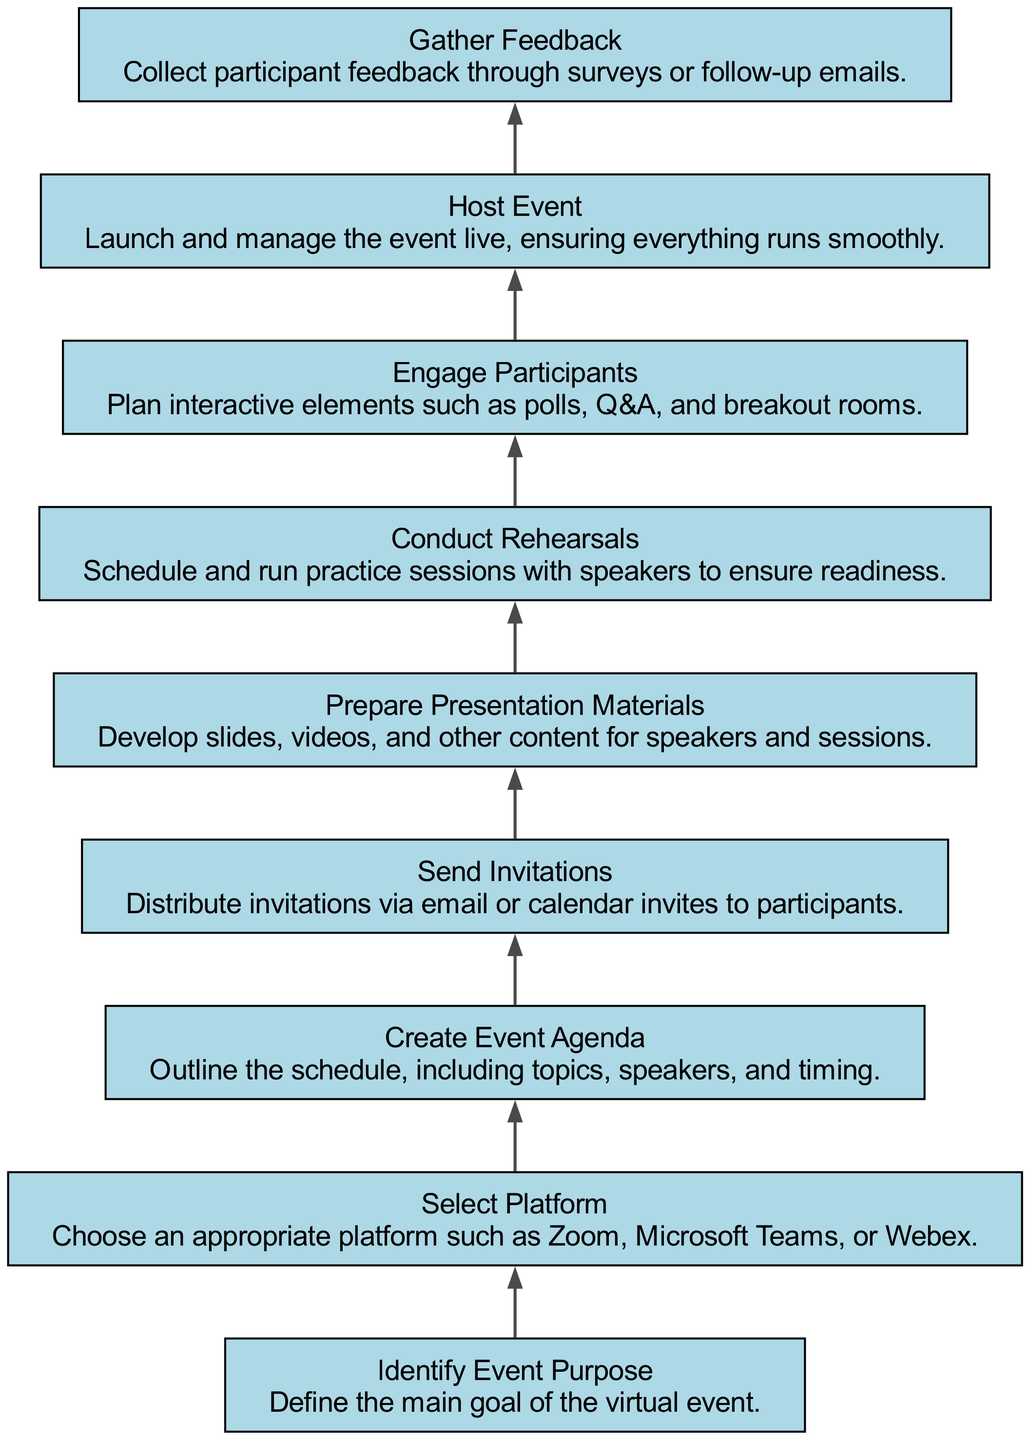What is the last step in organizing a virtual event? The last step in the diagram is "Gather Feedback," which is the final process after the event is hosted.
Answer: Gather Feedback How many elements are in the flow chart? There are nine elements represented as nodes in the flow chart. Each step in the organization of the virtual event is a distinct element.
Answer: Nine Which step directly follows "Send Invitations"? "Prepare Presentation Materials" directly follows "Send Invitations" in the flow of the diagram. This indicates that once invitations are sent, preparation of materials begins.
Answer: Prepare Presentation Materials What is the purpose of "Conduct Rehearsals"? "Conduct Rehearsals" is meant to ensure speakers are prepared and ready for the event, following the event agenda creation.
Answer: Ensure readiness Which two steps are connected directly in sequence before hosting the event? "Conduct Rehearsals" and "Engage Participants" are two steps that come directly before "Host Event," showing the preparation and engagement efforts leading up to the event.
Answer: Conduct Rehearsals and Engage Participants How does the "Select Platform" relate to the overall organization of the event? "Select Platform" is one of the first steps in the organization, indicating the choice of technology needs to happen early to facilitate other steps effectively.
Answer: Early choice for technology What is the function of "Engage Participants"? The function of "Engage Participants" is to enhance interaction during the event, such as through polls or breakout rooms, demonstrating an effort to keep attendees involved.
Answer: Enhance interaction After which step should feedback be collected? Feedback should be collected after the step "Host Event," as it aims to gather participant reactions post-event for future improvements.
Answer: Host Event What does the first element "Identify Event Purpose" contribute to the flow? "Identify Event Purpose" lays the foundation for all subsequent steps by defining the goal, ensuring that planning and execution focus on achieving that purpose.
Answer: Lays the foundation 